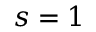<formula> <loc_0><loc_0><loc_500><loc_500>s = 1</formula> 